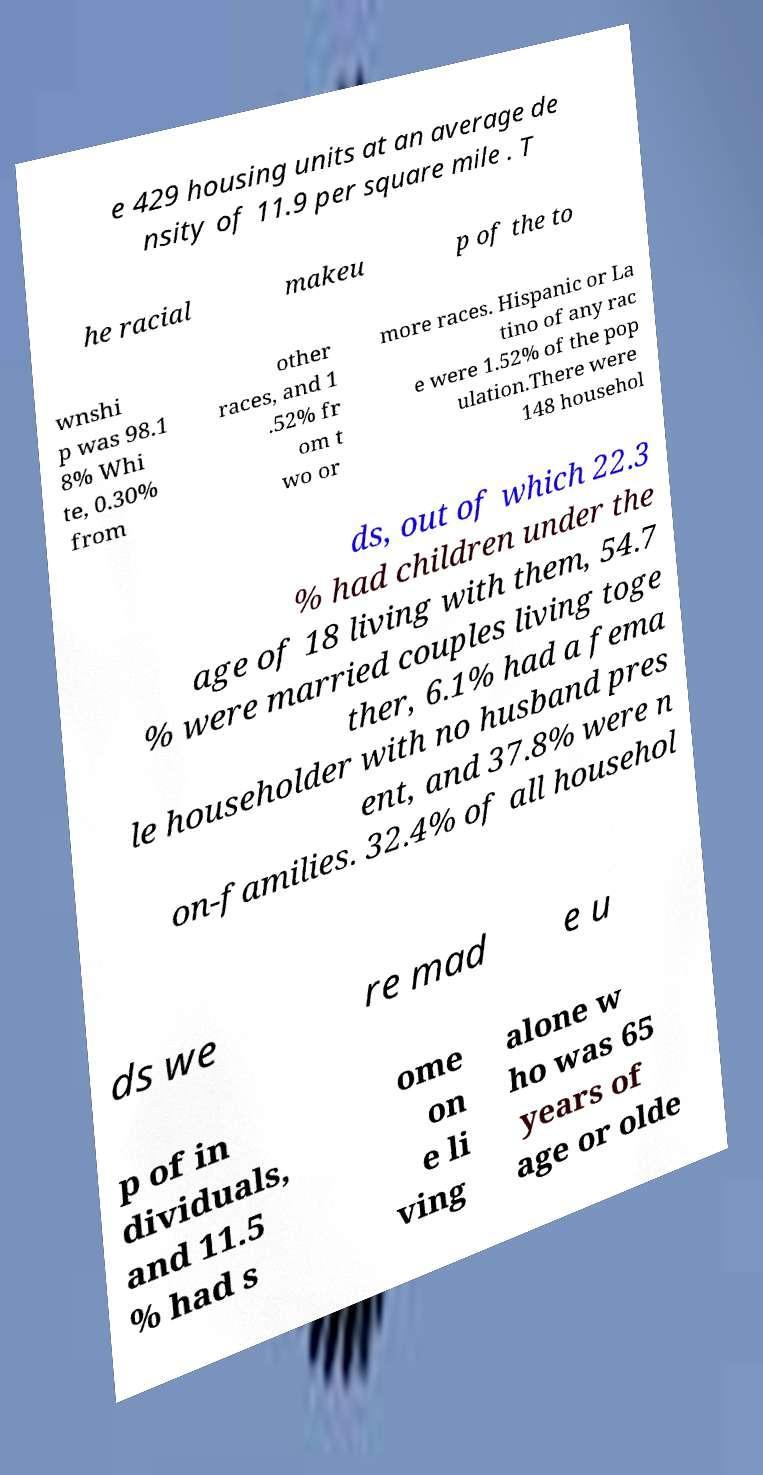Could you assist in decoding the text presented in this image and type it out clearly? e 429 housing units at an average de nsity of 11.9 per square mile . T he racial makeu p of the to wnshi p was 98.1 8% Whi te, 0.30% from other races, and 1 .52% fr om t wo or more races. Hispanic or La tino of any rac e were 1.52% of the pop ulation.There were 148 househol ds, out of which 22.3 % had children under the age of 18 living with them, 54.7 % were married couples living toge ther, 6.1% had a fema le householder with no husband pres ent, and 37.8% were n on-families. 32.4% of all househol ds we re mad e u p of in dividuals, and 11.5 % had s ome on e li ving alone w ho was 65 years of age or olde 